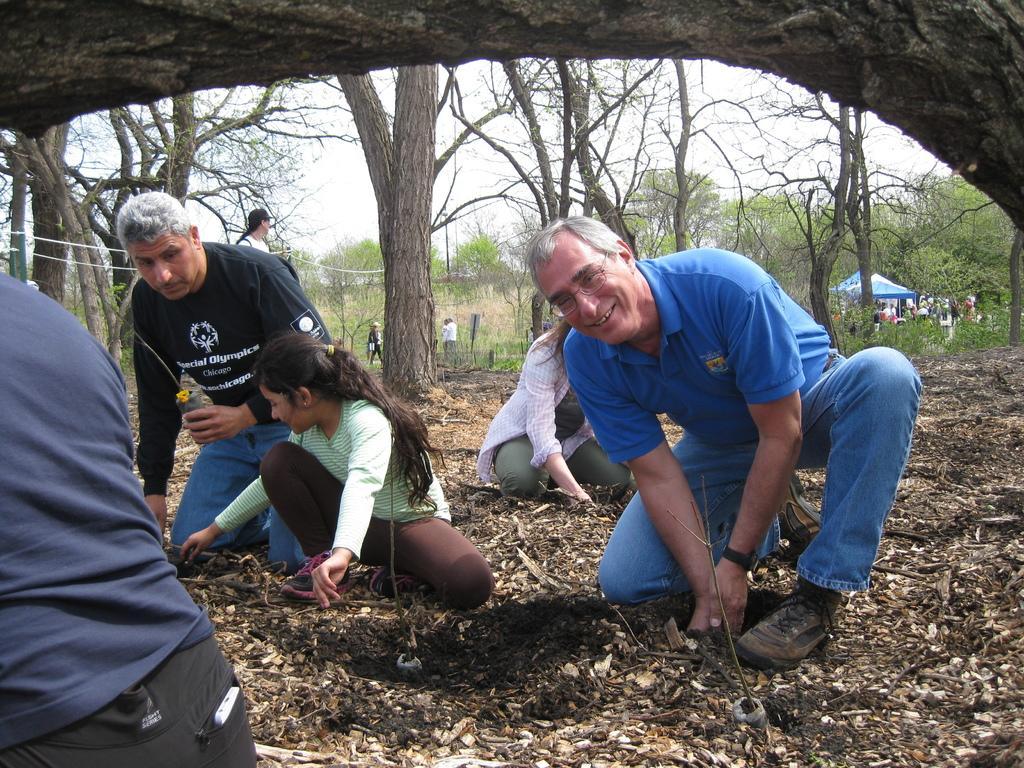Please provide a concise description of this image. In this image, I can see four persons kneeling on the ground. On the left side of the image, I can see another person. In the background, I can see the trees, few people, canopy tents and there is the sky. At the top of the image, I can see a tree trunk. 